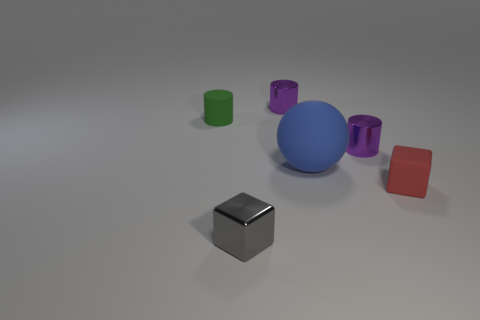Add 3 green metal spheres. How many objects exist? 9 Subtract all spheres. How many objects are left? 5 Subtract all green matte spheres. Subtract all tiny red blocks. How many objects are left? 5 Add 1 blue things. How many blue things are left? 2 Add 6 tiny blue metallic spheres. How many tiny blue metallic spheres exist? 6 Subtract 0 green balls. How many objects are left? 6 